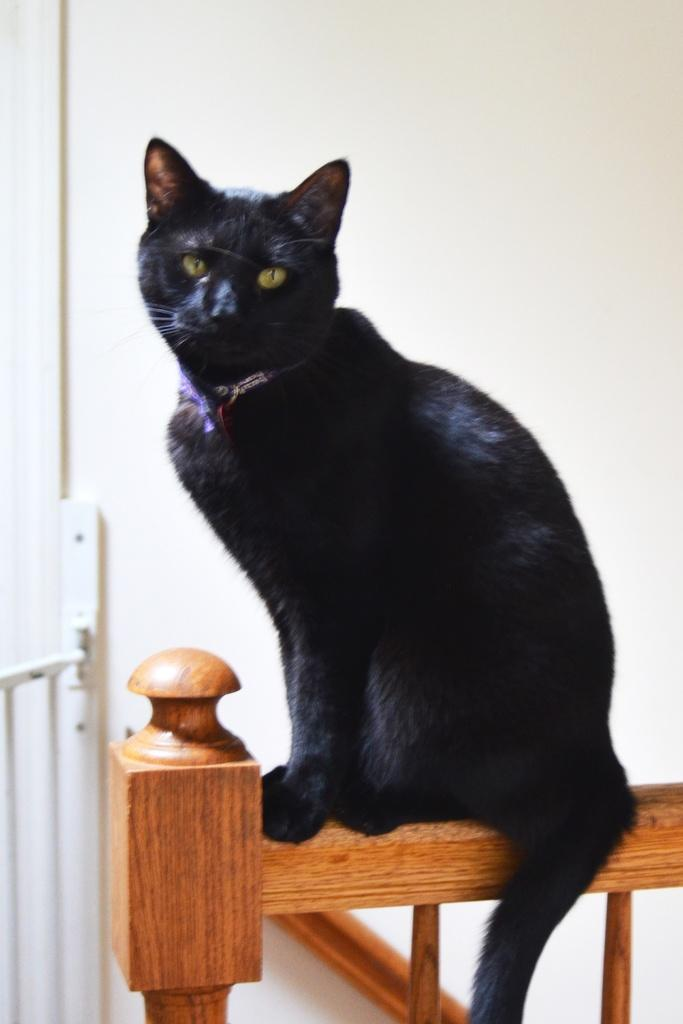What type of animal is in the image? There is a black cat in the image. Where is the cat located? The cat is sitting on a wooden fence. Are there any other objects or features in the image? Yes, there are some other objects in the left corner of the image. What does the alley smell like in the image? There is no alley present in the image, so it is not possible to determine what it might smell like. 